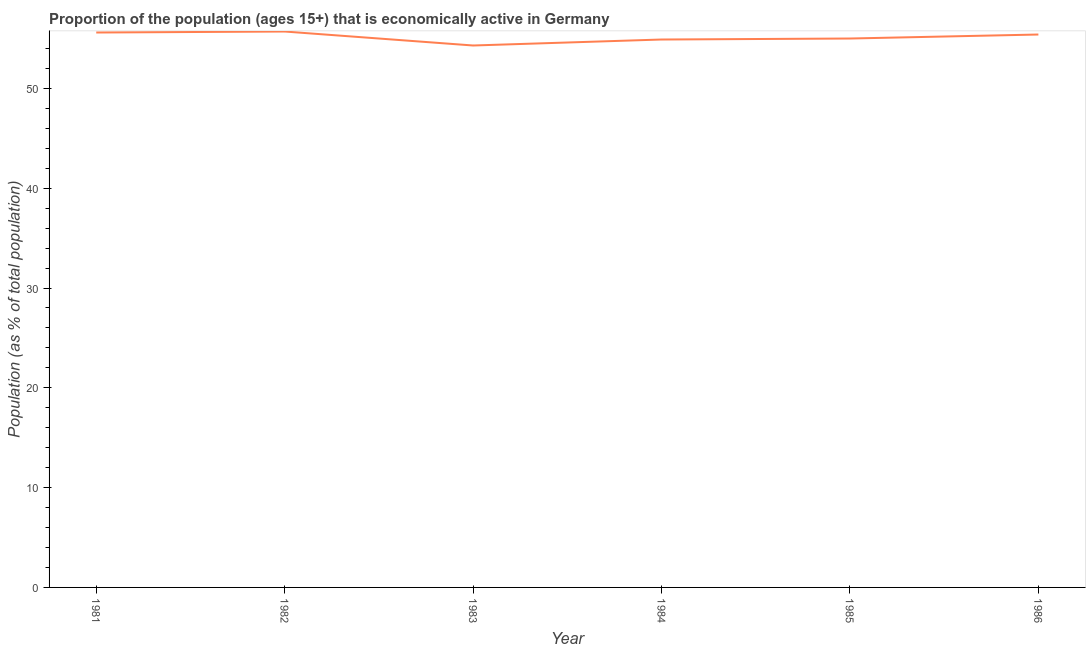What is the percentage of economically active population in 1984?
Give a very brief answer. 54.9. Across all years, what is the maximum percentage of economically active population?
Give a very brief answer. 55.7. Across all years, what is the minimum percentage of economically active population?
Your answer should be compact. 54.3. In which year was the percentage of economically active population minimum?
Keep it short and to the point. 1983. What is the sum of the percentage of economically active population?
Your answer should be compact. 330.9. What is the difference between the percentage of economically active population in 1982 and 1983?
Make the answer very short. 1.4. What is the average percentage of economically active population per year?
Provide a succinct answer. 55.15. What is the median percentage of economically active population?
Your response must be concise. 55.2. What is the ratio of the percentage of economically active population in 1984 to that in 1986?
Provide a short and direct response. 0.99. What is the difference between the highest and the second highest percentage of economically active population?
Ensure brevity in your answer.  0.1. What is the difference between the highest and the lowest percentage of economically active population?
Provide a succinct answer. 1.4. In how many years, is the percentage of economically active population greater than the average percentage of economically active population taken over all years?
Your answer should be compact. 3. How many years are there in the graph?
Your response must be concise. 6. What is the difference between two consecutive major ticks on the Y-axis?
Keep it short and to the point. 10. Does the graph contain any zero values?
Provide a short and direct response. No. What is the title of the graph?
Offer a terse response. Proportion of the population (ages 15+) that is economically active in Germany. What is the label or title of the Y-axis?
Offer a terse response. Population (as % of total population). What is the Population (as % of total population) of 1981?
Make the answer very short. 55.6. What is the Population (as % of total population) of 1982?
Keep it short and to the point. 55.7. What is the Population (as % of total population) in 1983?
Ensure brevity in your answer.  54.3. What is the Population (as % of total population) in 1984?
Keep it short and to the point. 54.9. What is the Population (as % of total population) of 1986?
Keep it short and to the point. 55.4. What is the difference between the Population (as % of total population) in 1981 and 1982?
Make the answer very short. -0.1. What is the difference between the Population (as % of total population) in 1981 and 1983?
Provide a short and direct response. 1.3. What is the difference between the Population (as % of total population) in 1981 and 1986?
Provide a succinct answer. 0.2. What is the difference between the Population (as % of total population) in 1982 and 1983?
Ensure brevity in your answer.  1.4. What is the difference between the Population (as % of total population) in 1982 and 1984?
Provide a succinct answer. 0.8. What is the difference between the Population (as % of total population) in 1983 and 1984?
Keep it short and to the point. -0.6. What is the difference between the Population (as % of total population) in 1983 and 1985?
Offer a very short reply. -0.7. What is the difference between the Population (as % of total population) in 1984 and 1985?
Provide a short and direct response. -0.1. What is the difference between the Population (as % of total population) in 1984 and 1986?
Your answer should be compact. -0.5. What is the difference between the Population (as % of total population) in 1985 and 1986?
Ensure brevity in your answer.  -0.4. What is the ratio of the Population (as % of total population) in 1981 to that in 1982?
Your answer should be very brief. 1. What is the ratio of the Population (as % of total population) in 1981 to that in 1984?
Your response must be concise. 1.01. What is the ratio of the Population (as % of total population) in 1981 to that in 1985?
Your answer should be very brief. 1.01. What is the ratio of the Population (as % of total population) in 1982 to that in 1986?
Make the answer very short. 1. What is the ratio of the Population (as % of total population) in 1983 to that in 1984?
Your answer should be compact. 0.99. What is the ratio of the Population (as % of total population) in 1983 to that in 1985?
Your answer should be very brief. 0.99. What is the ratio of the Population (as % of total population) in 1985 to that in 1986?
Keep it short and to the point. 0.99. 